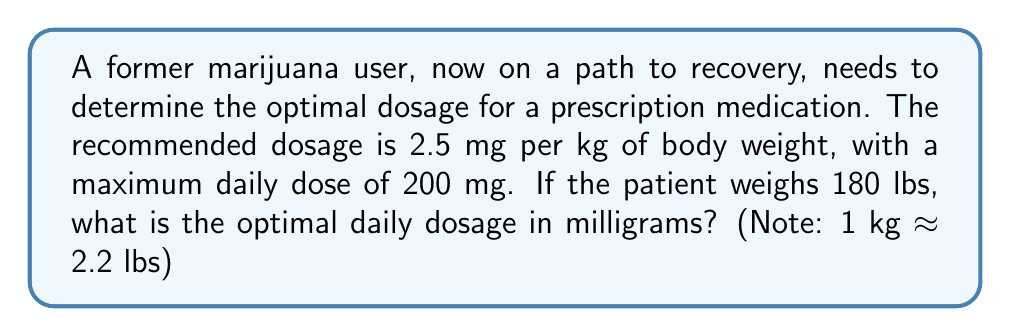Show me your answer to this math problem. Let's approach this step-by-step:

1) First, we need to convert the patient's weight from pounds to kilograms:
   $$ \text{Weight in kg} = \frac{180 \text{ lbs}}{2.2 \text{ lbs/kg}} \approx 81.82 \text{ kg} $$

2) Now, we can calculate the recommended dosage based on weight:
   $$ \text{Recommended dosage} = 2.5 \text{ mg/kg} \times 81.82 \text{ kg} = 204.55 \text{ mg} $$

3) However, we need to check if this exceeds the maximum daily dose of 200 mg:
   $$ 204.55 \text{ mg} > 200 \text{ mg} $$

4) Since the calculated dosage exceeds the maximum, we need to use the maximum daily dose as the optimal dosage.

Therefore, the optimal daily dosage for this patient is 200 mg.
Answer: 200 mg 